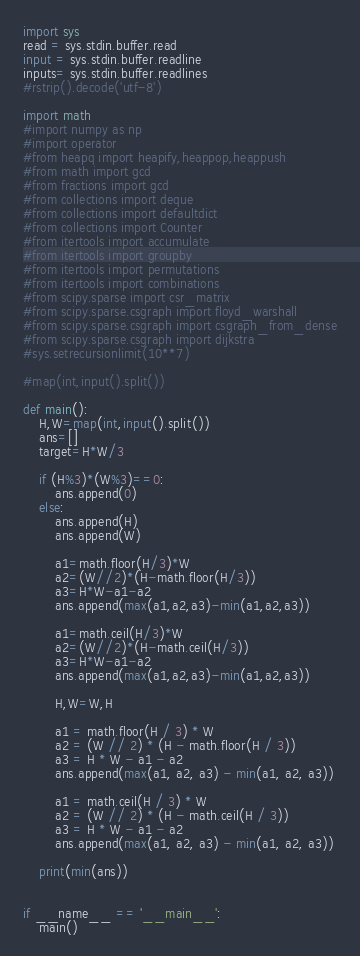Convert code to text. <code><loc_0><loc_0><loc_500><loc_500><_Python_>import sys
read = sys.stdin.buffer.read
input = sys.stdin.buffer.readline
inputs= sys.stdin.buffer.readlines
#rstrip().decode('utf-8')

import math
#import numpy as np
#import operator
#from heapq import heapify,heappop,heappush
#from math import gcd
#from fractions import gcd
#from collections import deque
#from collections import defaultdict
#from collections import Counter
#from itertools import accumulate
#from itertools import groupby
#from itertools import permutations
#from itertools import combinations
#from scipy.sparse import csr_matrix
#from scipy.sparse.csgraph import floyd_warshall
#from scipy.sparse.csgraph import csgraph_from_dense
#from scipy.sparse.csgraph import dijkstra
#sys.setrecursionlimit(10**7)

#map(int,input().split())

def main():
	H,W=map(int,input().split())
	ans=[]
	target=H*W/3
	
	if (H%3)*(W%3)==0:
		ans.append(0)
	else:
		ans.append(H)
		ans.append(W)
		
		a1=math.floor(H/3)*W
		a2=(W//2)*(H-math.floor(H/3))
		a3=H*W-a1-a2
		ans.append(max(a1,a2,a3)-min(a1,a2,a3))
		
		a1=math.ceil(H/3)*W
		a2=(W//2)*(H-math.ceil(H/3))
		a3=H*W-a1-a2
		ans.append(max(a1,a2,a3)-min(a1,a2,a3))
		
		H,W=W,H
		
		a1 = math.floor(H / 3) * W
		a2 = (W // 2) * (H - math.floor(H / 3))
		a3 = H * W - a1 - a2
		ans.append(max(a1, a2, a3) - min(a1, a2, a3))
		
		a1 = math.ceil(H / 3) * W
		a2 = (W // 2) * (H - math.ceil(H / 3))
		a3 = H * W - a1 - a2
		ans.append(max(a1, a2, a3) - min(a1, a2, a3))
		
	print(min(ans))


if __name__ == '__main__':
	main()</code> 